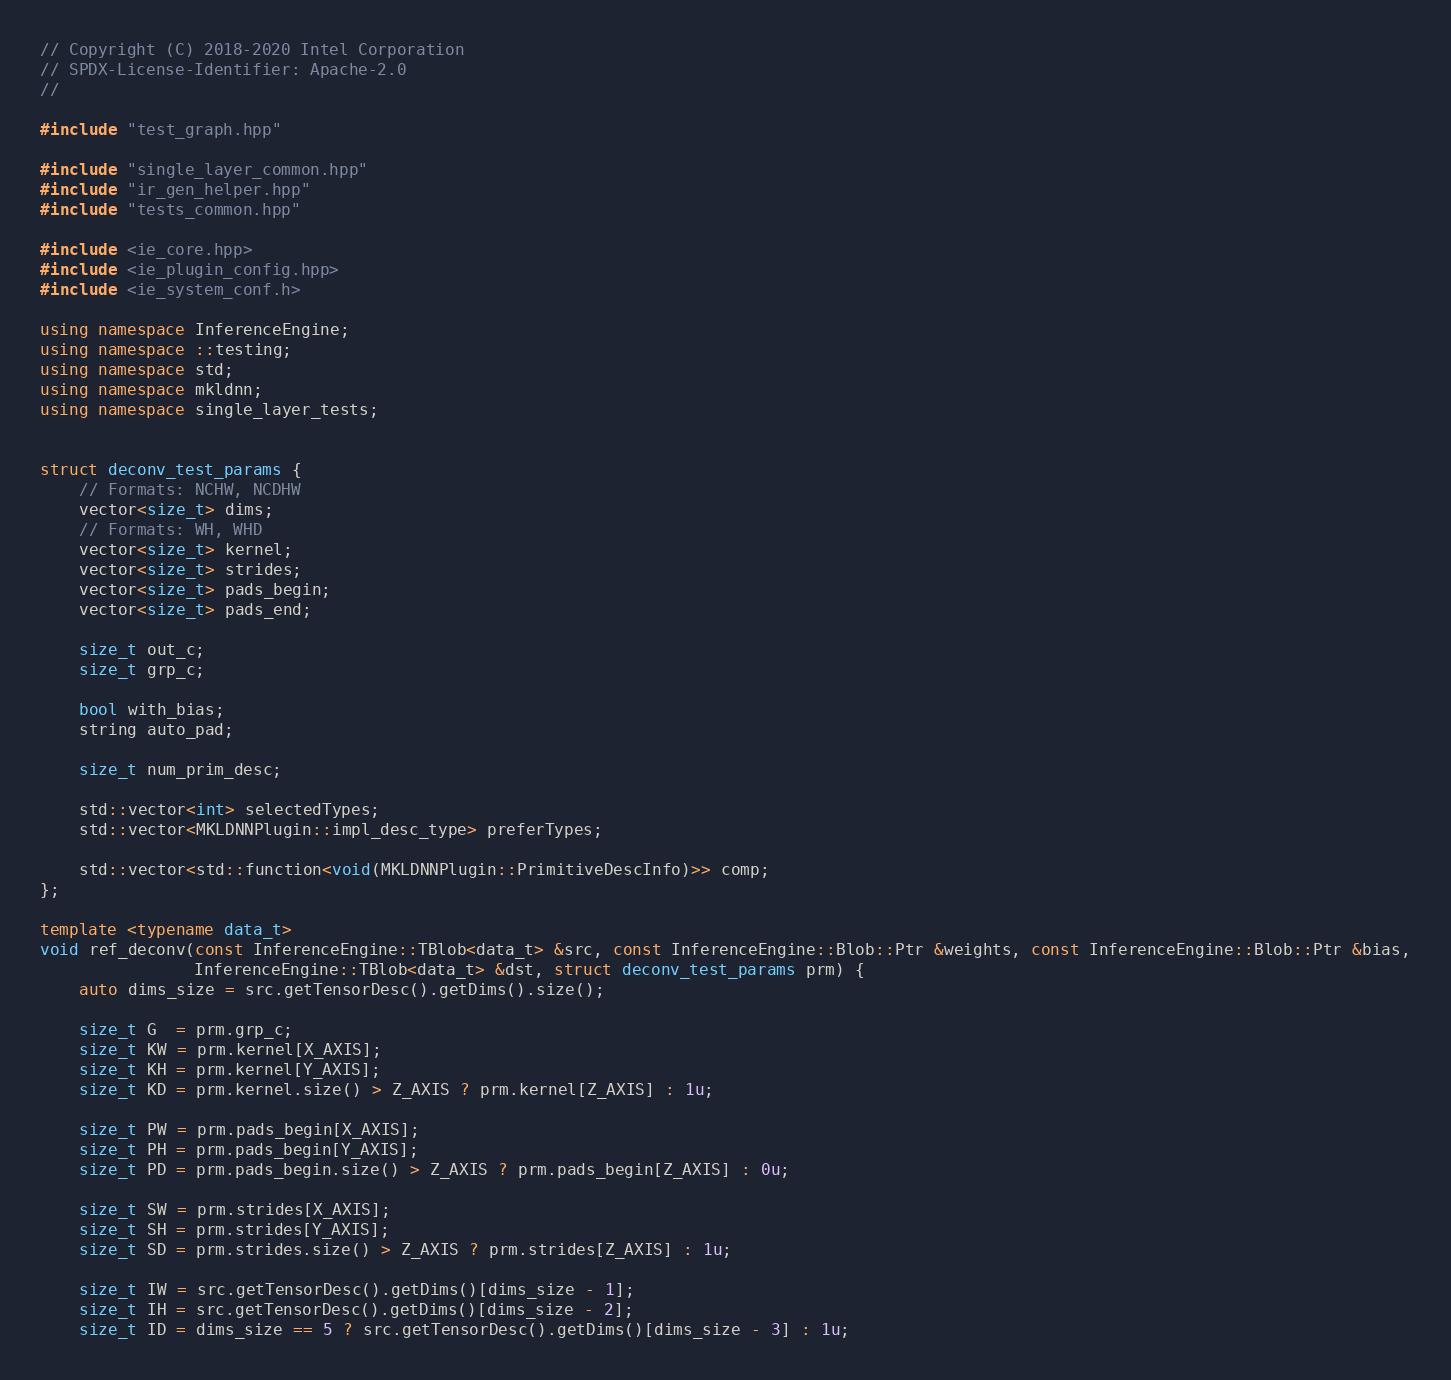<code> <loc_0><loc_0><loc_500><loc_500><_C++_>// Copyright (C) 2018-2020 Intel Corporation
// SPDX-License-Identifier: Apache-2.0
//

#include "test_graph.hpp"

#include "single_layer_common.hpp"
#include "ir_gen_helper.hpp"
#include "tests_common.hpp"

#include <ie_core.hpp>
#include <ie_plugin_config.hpp>
#include <ie_system_conf.h>

using namespace InferenceEngine;
using namespace ::testing;
using namespace std;
using namespace mkldnn;
using namespace single_layer_tests;


struct deconv_test_params {
    // Formats: NCHW, NCDHW
    vector<size_t> dims;
    // Formats: WH, WHD
    vector<size_t> kernel;
    vector<size_t> strides;
    vector<size_t> pads_begin;
    vector<size_t> pads_end;

    size_t out_c;
    size_t grp_c;

    bool with_bias;
    string auto_pad;

    size_t num_prim_desc;

    std::vector<int> selectedTypes;
    std::vector<MKLDNNPlugin::impl_desc_type> preferTypes;

    std::vector<std::function<void(MKLDNNPlugin::PrimitiveDescInfo)>> comp;
};

template <typename data_t>
void ref_deconv(const InferenceEngine::TBlob<data_t> &src, const InferenceEngine::Blob::Ptr &weights, const InferenceEngine::Blob::Ptr &bias,
                InferenceEngine::TBlob<data_t> &dst, struct deconv_test_params prm) {
    auto dims_size = src.getTensorDesc().getDims().size();

    size_t G  = prm.grp_c;
    size_t KW = prm.kernel[X_AXIS];
    size_t KH = prm.kernel[Y_AXIS];
    size_t KD = prm.kernel.size() > Z_AXIS ? prm.kernel[Z_AXIS] : 1u;

    size_t PW = prm.pads_begin[X_AXIS];
    size_t PH = prm.pads_begin[Y_AXIS];
    size_t PD = prm.pads_begin.size() > Z_AXIS ? prm.pads_begin[Z_AXIS] : 0u;

    size_t SW = prm.strides[X_AXIS];
    size_t SH = prm.strides[Y_AXIS];
    size_t SD = prm.strides.size() > Z_AXIS ? prm.strides[Z_AXIS] : 1u;

    size_t IW = src.getTensorDesc().getDims()[dims_size - 1];
    size_t IH = src.getTensorDesc().getDims()[dims_size - 2];
    size_t ID = dims_size == 5 ? src.getTensorDesc().getDims()[dims_size - 3] : 1u;</code> 